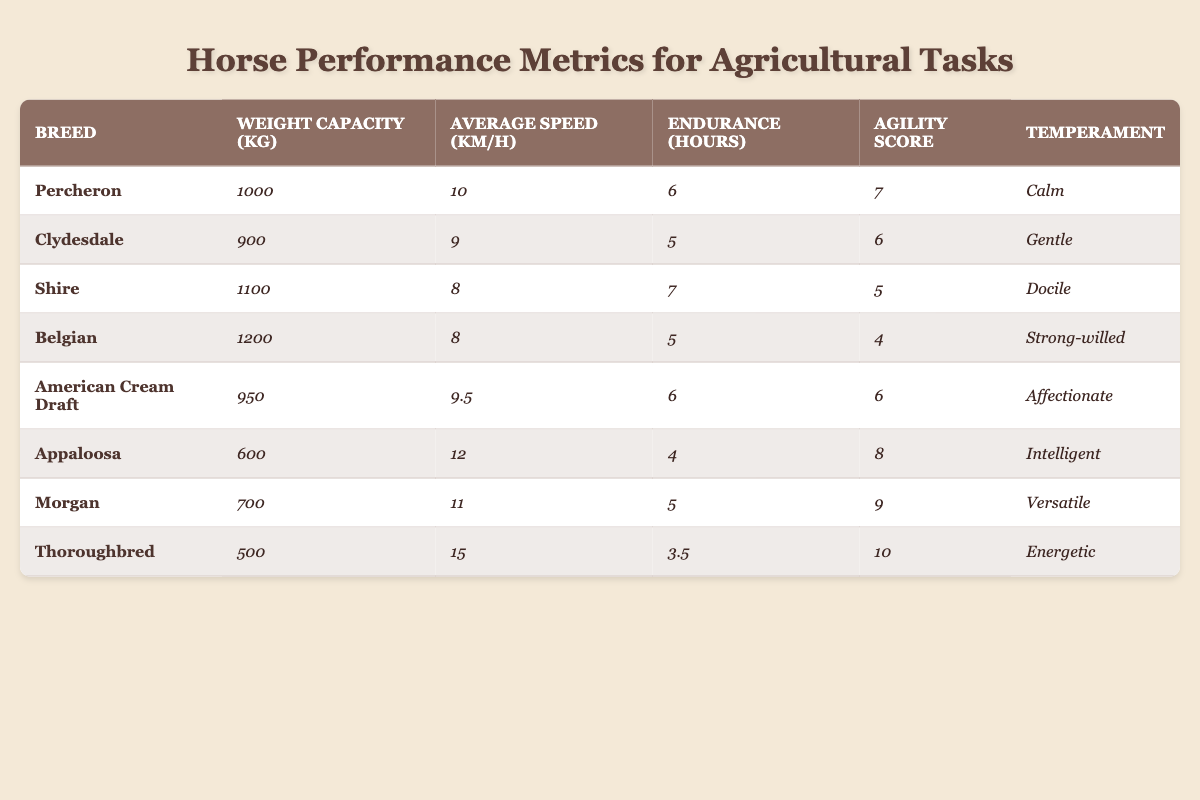What is the weight capacity of the Belgian horse? The table indicates that the Belgian breed has a weight capacity of 1200 kg.
Answer: 1200 kg Which horse breeds have an average speed greater than 10 km/h? The table lists the Appaloosa (12 km/h), Morgan (11 km/h), and Thoroughbred (15 km/h) as breeds with average speeds greater than 10 km/h.
Answer: Appaloosa, Morgan, Thoroughbred What is the endurance of the Clydesdale horse? According to the table, the Clydesdale has an endurance of 5 hours.
Answer: 5 hours Which breed has the highest agility score, and what is that score? The Thoroughbred has the highest agility score of 10 according to the table.
Answer: Thoroughbred, 10 Calculate the average weight capacity of the horses listed. The weight capacities are 1000 kg, 900 kg, 1100 kg, 1200 kg, 950 kg, 600 kg, 700 kg, and 500 kg. Adding these values gives a total of 5050 kg, and dividing by 8 (the number of breeds) gives an average of 631.25 kg.
Answer: 631.25 kg Does the Appaloosa have a higher weight capacity than the Morgan? The Appaloosa's weight capacity is 600 kg, and the Morgan's is 700 kg. Since 600 kg is less than 700 kg, the statement is false.
Answer: No What breed has the lowest endurance, and how many hours is it? The Thoroughbred has the lowest endurance at 3.5 hours, making it the breed with the least endurance in the table.
Answer: Thoroughbred, 3.5 hours If you compare the average speed of the Percheron and Shire, which is faster? The Percheron has an average speed of 10 km/h, while the Shire has an average speed of 8 km/h, making the Percheron faster.
Answer: Percheron How many breeds have a temperament classified as 'Gentle' or 'Calm'? The Clydesdale is classified as ‘Gentle’, while the Percheron is classified as ‘Calm’. Therefore, there are 2 breeds that fall into this category.
Answer: 2 breeds What is the difference in weight capacity between the Belgian and the Thoroughbred? The Belgian's weight capacity is 1200 kg, and the Thoroughbred's is 500 kg. The difference is 1200 kg - 500 kg = 700 kg.
Answer: 700 kg 